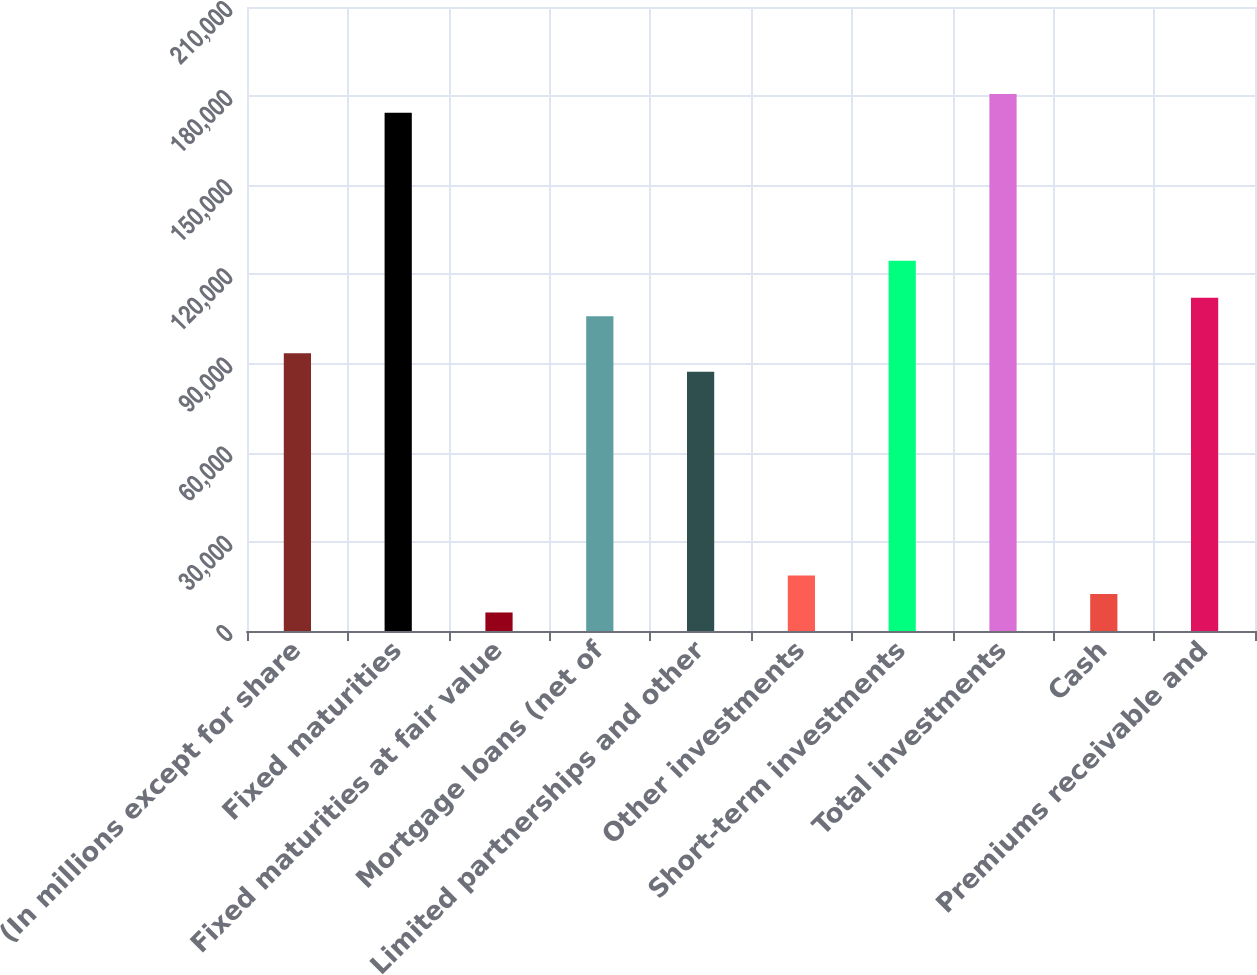Convert chart. <chart><loc_0><loc_0><loc_500><loc_500><bar_chart><fcel>(In millions except for share<fcel>Fixed maturities<fcel>Fixed maturities at fair value<fcel>Mortgage loans (net of<fcel>Limited partnerships and other<fcel>Other investments<fcel>Short-term investments<fcel>Total investments<fcel>Cash<fcel>Premiums receivable and<nl><fcel>93458.5<fcel>174452<fcel>6234.3<fcel>105919<fcel>87228.2<fcel>18694.9<fcel>124610<fcel>180683<fcel>12464.6<fcel>112149<nl></chart> 